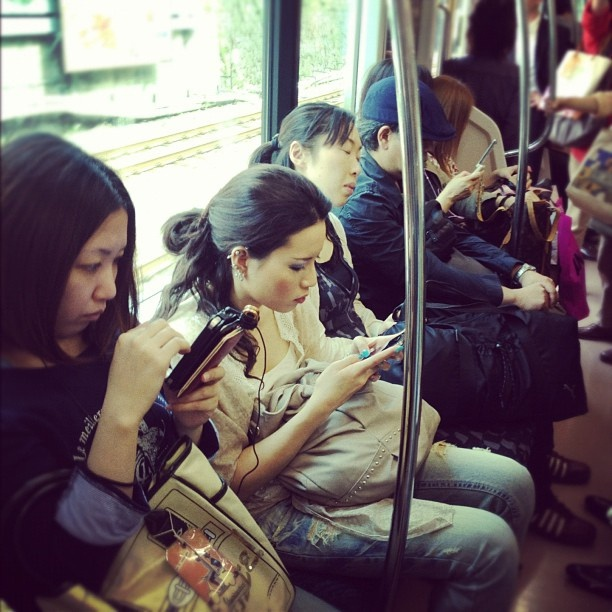Describe the objects in this image and their specific colors. I can see people in darkgray, black, gray, and tan tones, people in darkgray, black, gray, and tan tones, people in darkgray, black, navy, and gray tones, handbag in darkgray, black, gray, and tan tones, and handbag in darkgray, gray, and black tones in this image. 